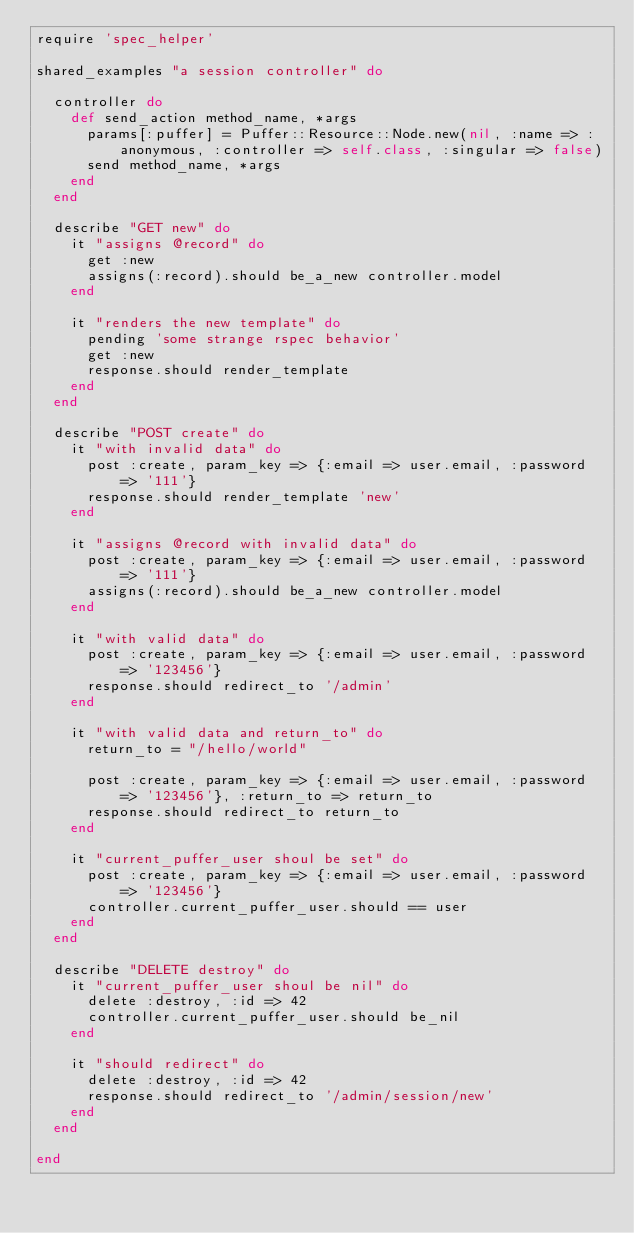<code> <loc_0><loc_0><loc_500><loc_500><_Ruby_>require 'spec_helper'

shared_examples "a session controller" do

  controller do
    def send_action method_name, *args
      params[:puffer] = Puffer::Resource::Node.new(nil, :name => :anonymous, :controller => self.class, :singular => false)
      send method_name, *args
    end
  end

  describe "GET new" do
    it "assigns @record" do
      get :new
      assigns(:record).should be_a_new controller.model
    end

    it "renders the new template" do
      pending 'some strange rspec behavior'
      get :new
      response.should render_template
    end
  end

  describe "POST create" do
    it "with invalid data" do
      post :create, param_key => {:email => user.email, :password => '111'}
      response.should render_template 'new'
    end

    it "assigns @record with invalid data" do
      post :create, param_key => {:email => user.email, :password => '111'}
      assigns(:record).should be_a_new controller.model
    end

    it "with valid data" do
      post :create, param_key => {:email => user.email, :password => '123456'}
      response.should redirect_to '/admin'
    end

    it "with valid data and return_to" do
      return_to = "/hello/world"

      post :create, param_key => {:email => user.email, :password => '123456'}, :return_to => return_to
      response.should redirect_to return_to
    end

    it "current_puffer_user shoul be set" do
      post :create, param_key => {:email => user.email, :password => '123456'}
      controller.current_puffer_user.should == user
    end
  end

  describe "DELETE destroy" do
    it "current_puffer_user shoul be nil" do
      delete :destroy, :id => 42
      controller.current_puffer_user.should be_nil
    end

    it "should redirect" do
      delete :destroy, :id => 42
      response.should redirect_to '/admin/session/new'
    end
  end

end</code> 